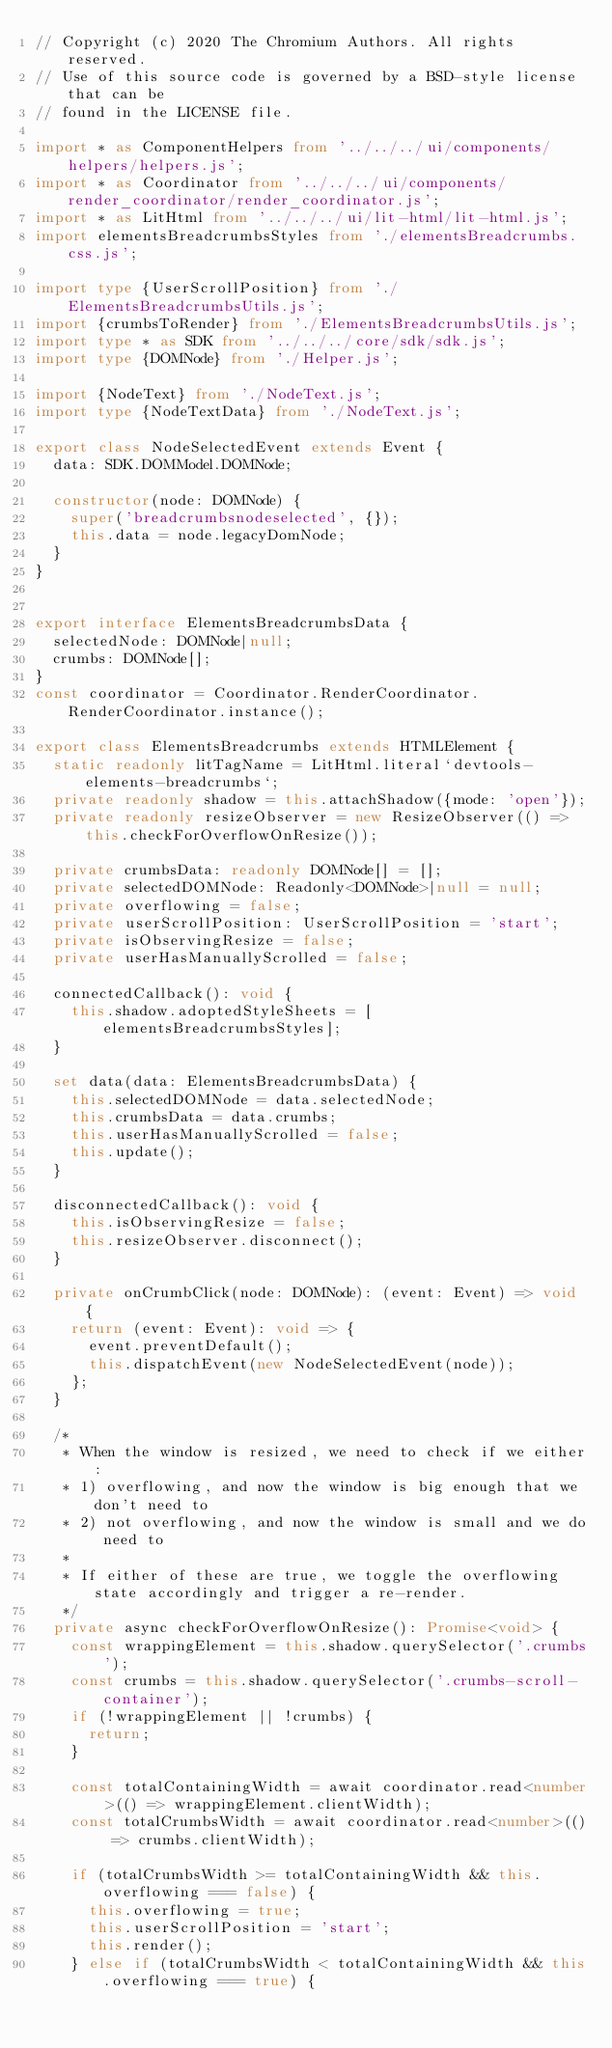Convert code to text. <code><loc_0><loc_0><loc_500><loc_500><_TypeScript_>// Copyright (c) 2020 The Chromium Authors. All rights reserved.
// Use of this source code is governed by a BSD-style license that can be
// found in the LICENSE file.

import * as ComponentHelpers from '../../../ui/components/helpers/helpers.js';
import * as Coordinator from '../../../ui/components/render_coordinator/render_coordinator.js';
import * as LitHtml from '../../../ui/lit-html/lit-html.js';
import elementsBreadcrumbsStyles from './elementsBreadcrumbs.css.js';

import type {UserScrollPosition} from './ElementsBreadcrumbsUtils.js';
import {crumbsToRender} from './ElementsBreadcrumbsUtils.js';
import type * as SDK from '../../../core/sdk/sdk.js';
import type {DOMNode} from './Helper.js';

import {NodeText} from './NodeText.js';
import type {NodeTextData} from './NodeText.js';

export class NodeSelectedEvent extends Event {
  data: SDK.DOMModel.DOMNode;

  constructor(node: DOMNode) {
    super('breadcrumbsnodeselected', {});
    this.data = node.legacyDomNode;
  }
}


export interface ElementsBreadcrumbsData {
  selectedNode: DOMNode|null;
  crumbs: DOMNode[];
}
const coordinator = Coordinator.RenderCoordinator.RenderCoordinator.instance();

export class ElementsBreadcrumbs extends HTMLElement {
  static readonly litTagName = LitHtml.literal`devtools-elements-breadcrumbs`;
  private readonly shadow = this.attachShadow({mode: 'open'});
  private readonly resizeObserver = new ResizeObserver(() => this.checkForOverflowOnResize());

  private crumbsData: readonly DOMNode[] = [];
  private selectedDOMNode: Readonly<DOMNode>|null = null;
  private overflowing = false;
  private userScrollPosition: UserScrollPosition = 'start';
  private isObservingResize = false;
  private userHasManuallyScrolled = false;

  connectedCallback(): void {
    this.shadow.adoptedStyleSheets = [elementsBreadcrumbsStyles];
  }

  set data(data: ElementsBreadcrumbsData) {
    this.selectedDOMNode = data.selectedNode;
    this.crumbsData = data.crumbs;
    this.userHasManuallyScrolled = false;
    this.update();
  }

  disconnectedCallback(): void {
    this.isObservingResize = false;
    this.resizeObserver.disconnect();
  }

  private onCrumbClick(node: DOMNode): (event: Event) => void {
    return (event: Event): void => {
      event.preventDefault();
      this.dispatchEvent(new NodeSelectedEvent(node));
    };
  }

  /*
   * When the window is resized, we need to check if we either:
   * 1) overflowing, and now the window is big enough that we don't need to
   * 2) not overflowing, and now the window is small and we do need to
   *
   * If either of these are true, we toggle the overflowing state accordingly and trigger a re-render.
   */
  private async checkForOverflowOnResize(): Promise<void> {
    const wrappingElement = this.shadow.querySelector('.crumbs');
    const crumbs = this.shadow.querySelector('.crumbs-scroll-container');
    if (!wrappingElement || !crumbs) {
      return;
    }

    const totalContainingWidth = await coordinator.read<number>(() => wrappingElement.clientWidth);
    const totalCrumbsWidth = await coordinator.read<number>(() => crumbs.clientWidth);

    if (totalCrumbsWidth >= totalContainingWidth && this.overflowing === false) {
      this.overflowing = true;
      this.userScrollPosition = 'start';
      this.render();
    } else if (totalCrumbsWidth < totalContainingWidth && this.overflowing === true) {</code> 